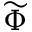Convert formula to latex. <formula><loc_0><loc_0><loc_500><loc_500>\widetilde { \Phi }</formula> 